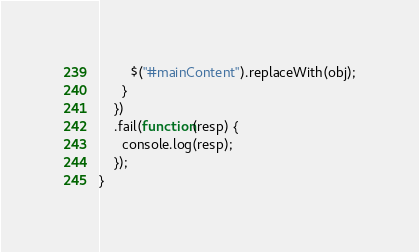<code> <loc_0><loc_0><loc_500><loc_500><_JavaScript_>        $("#mainContent").replaceWith(obj);
      }
    })
    .fail(function(resp) {
      console.log(resp);
    });
}
</code> 